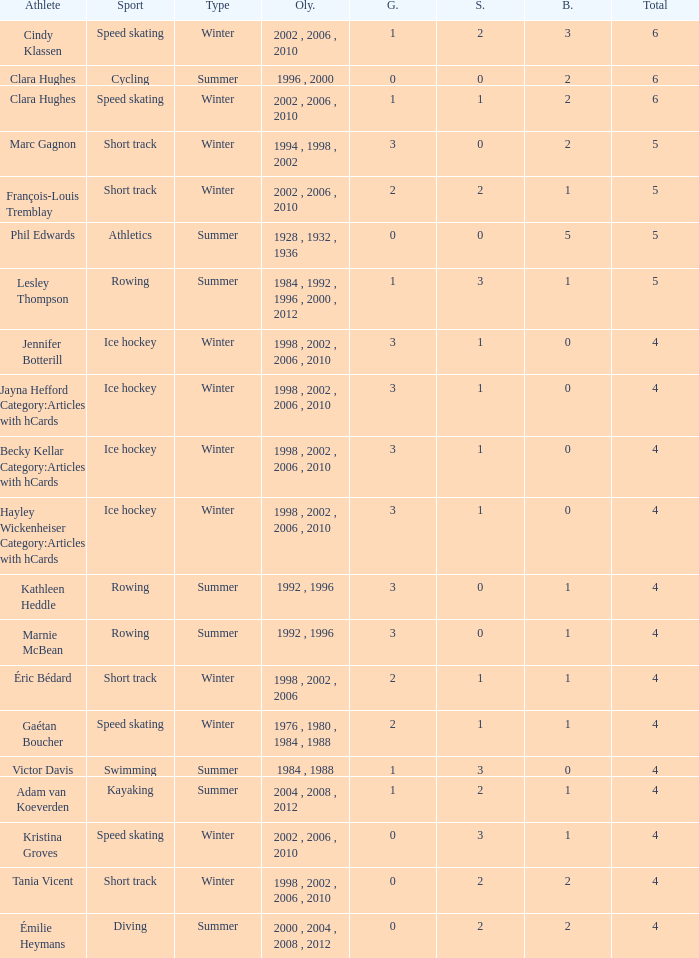What is the average gold of the winter athlete with 1 bronze, less than 3 silver, and less than 4 total medals? None. 